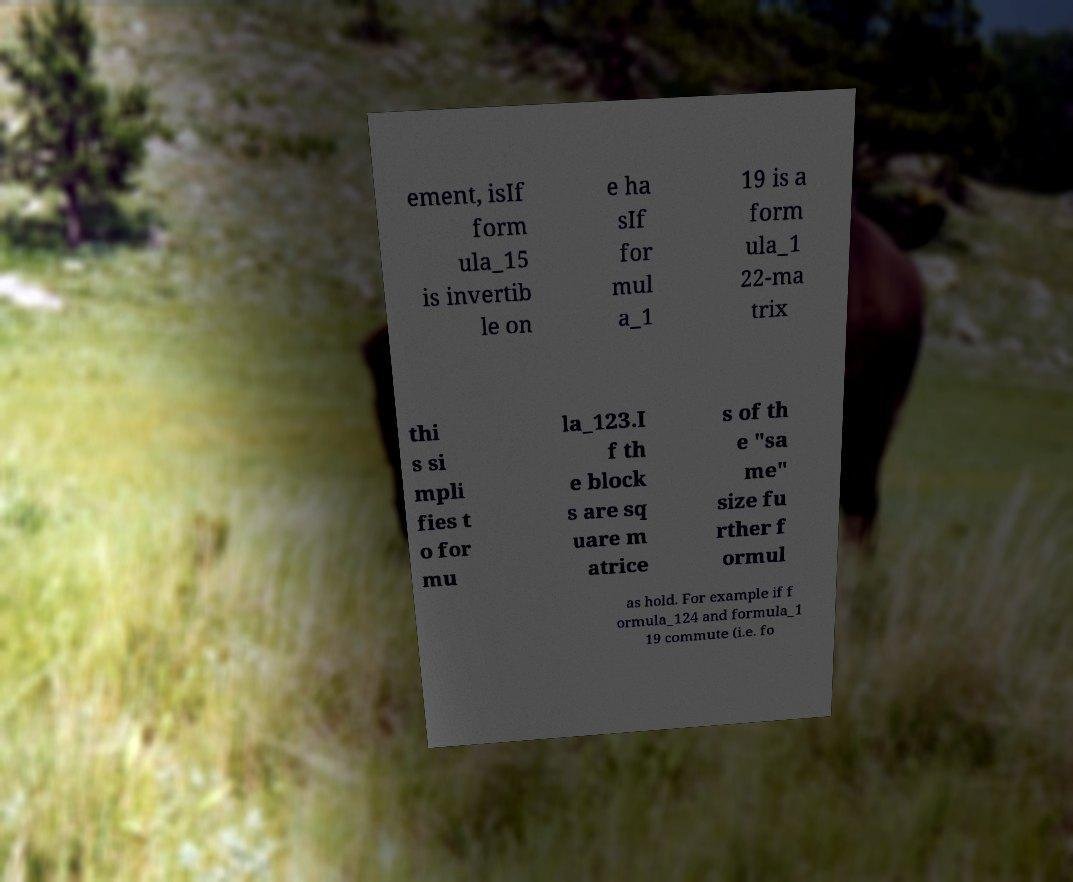Could you extract and type out the text from this image? ement, isIf form ula_15 is invertib le on e ha sIf for mul a_1 19 is a form ula_1 22-ma trix thi s si mpli fies t o for mu la_123.I f th e block s are sq uare m atrice s of th e "sa me" size fu rther f ormul as hold. For example if f ormula_124 and formula_1 19 commute (i.e. fo 